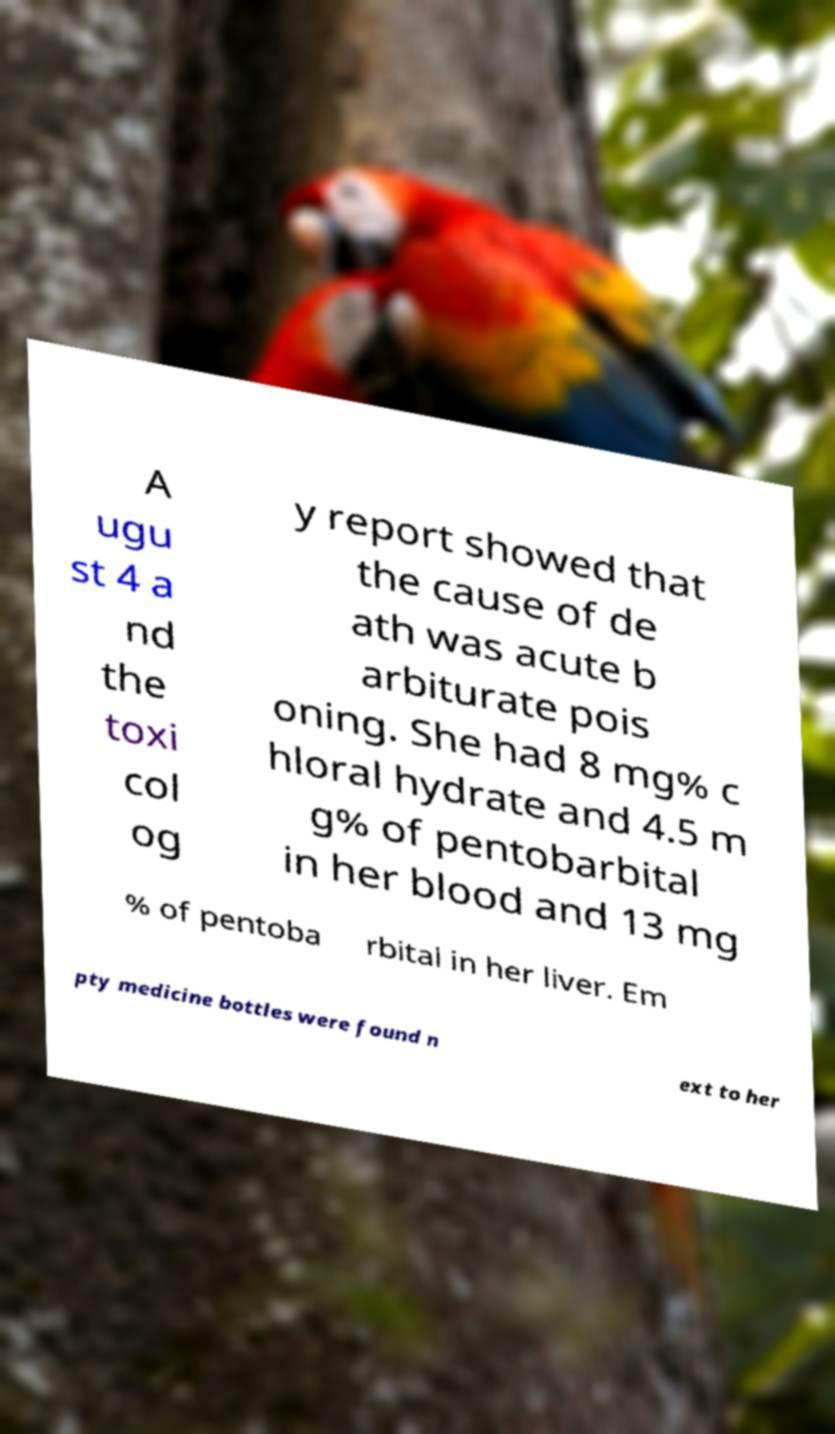Can you accurately transcribe the text from the provided image for me? A ugu st 4 a nd the toxi col og y report showed that the cause of de ath was acute b arbiturate pois oning. She had 8 mg% c hloral hydrate and 4.5 m g% of pentobarbital in her blood and 13 mg % of pentoba rbital in her liver. Em pty medicine bottles were found n ext to her 